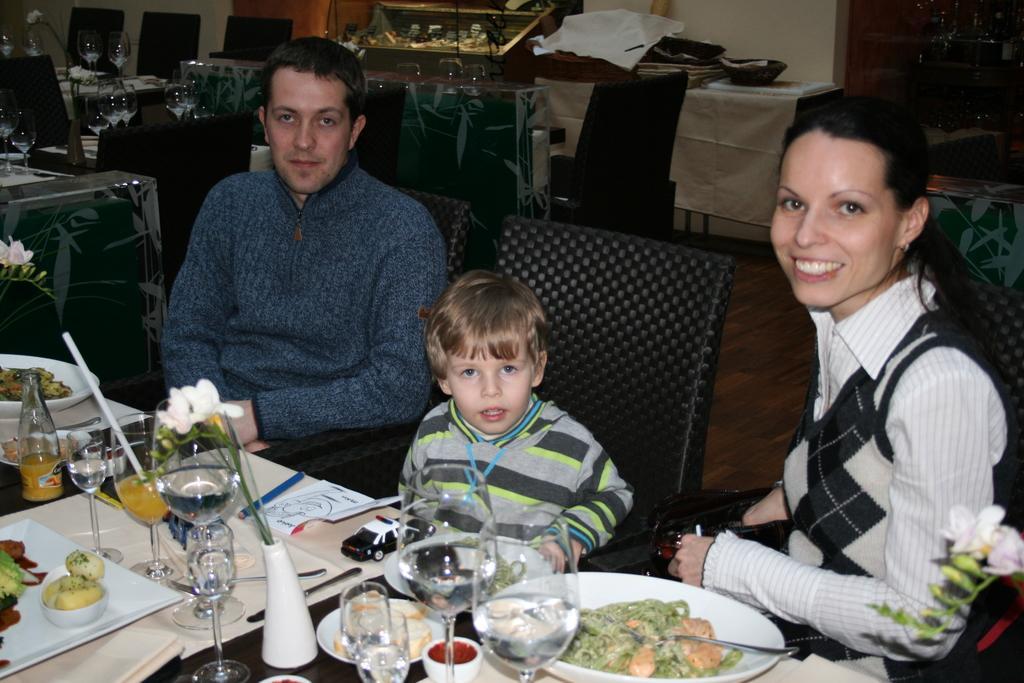How would you summarize this image in a sentence or two? In this Image I see a man, a boy and a woman who are sitting on chairs and this woman is smiling. I can also see there is a table in front of them on which there are many things. In the background I see many chairs and tables and many things on it. 